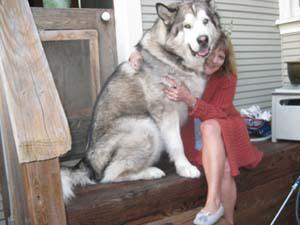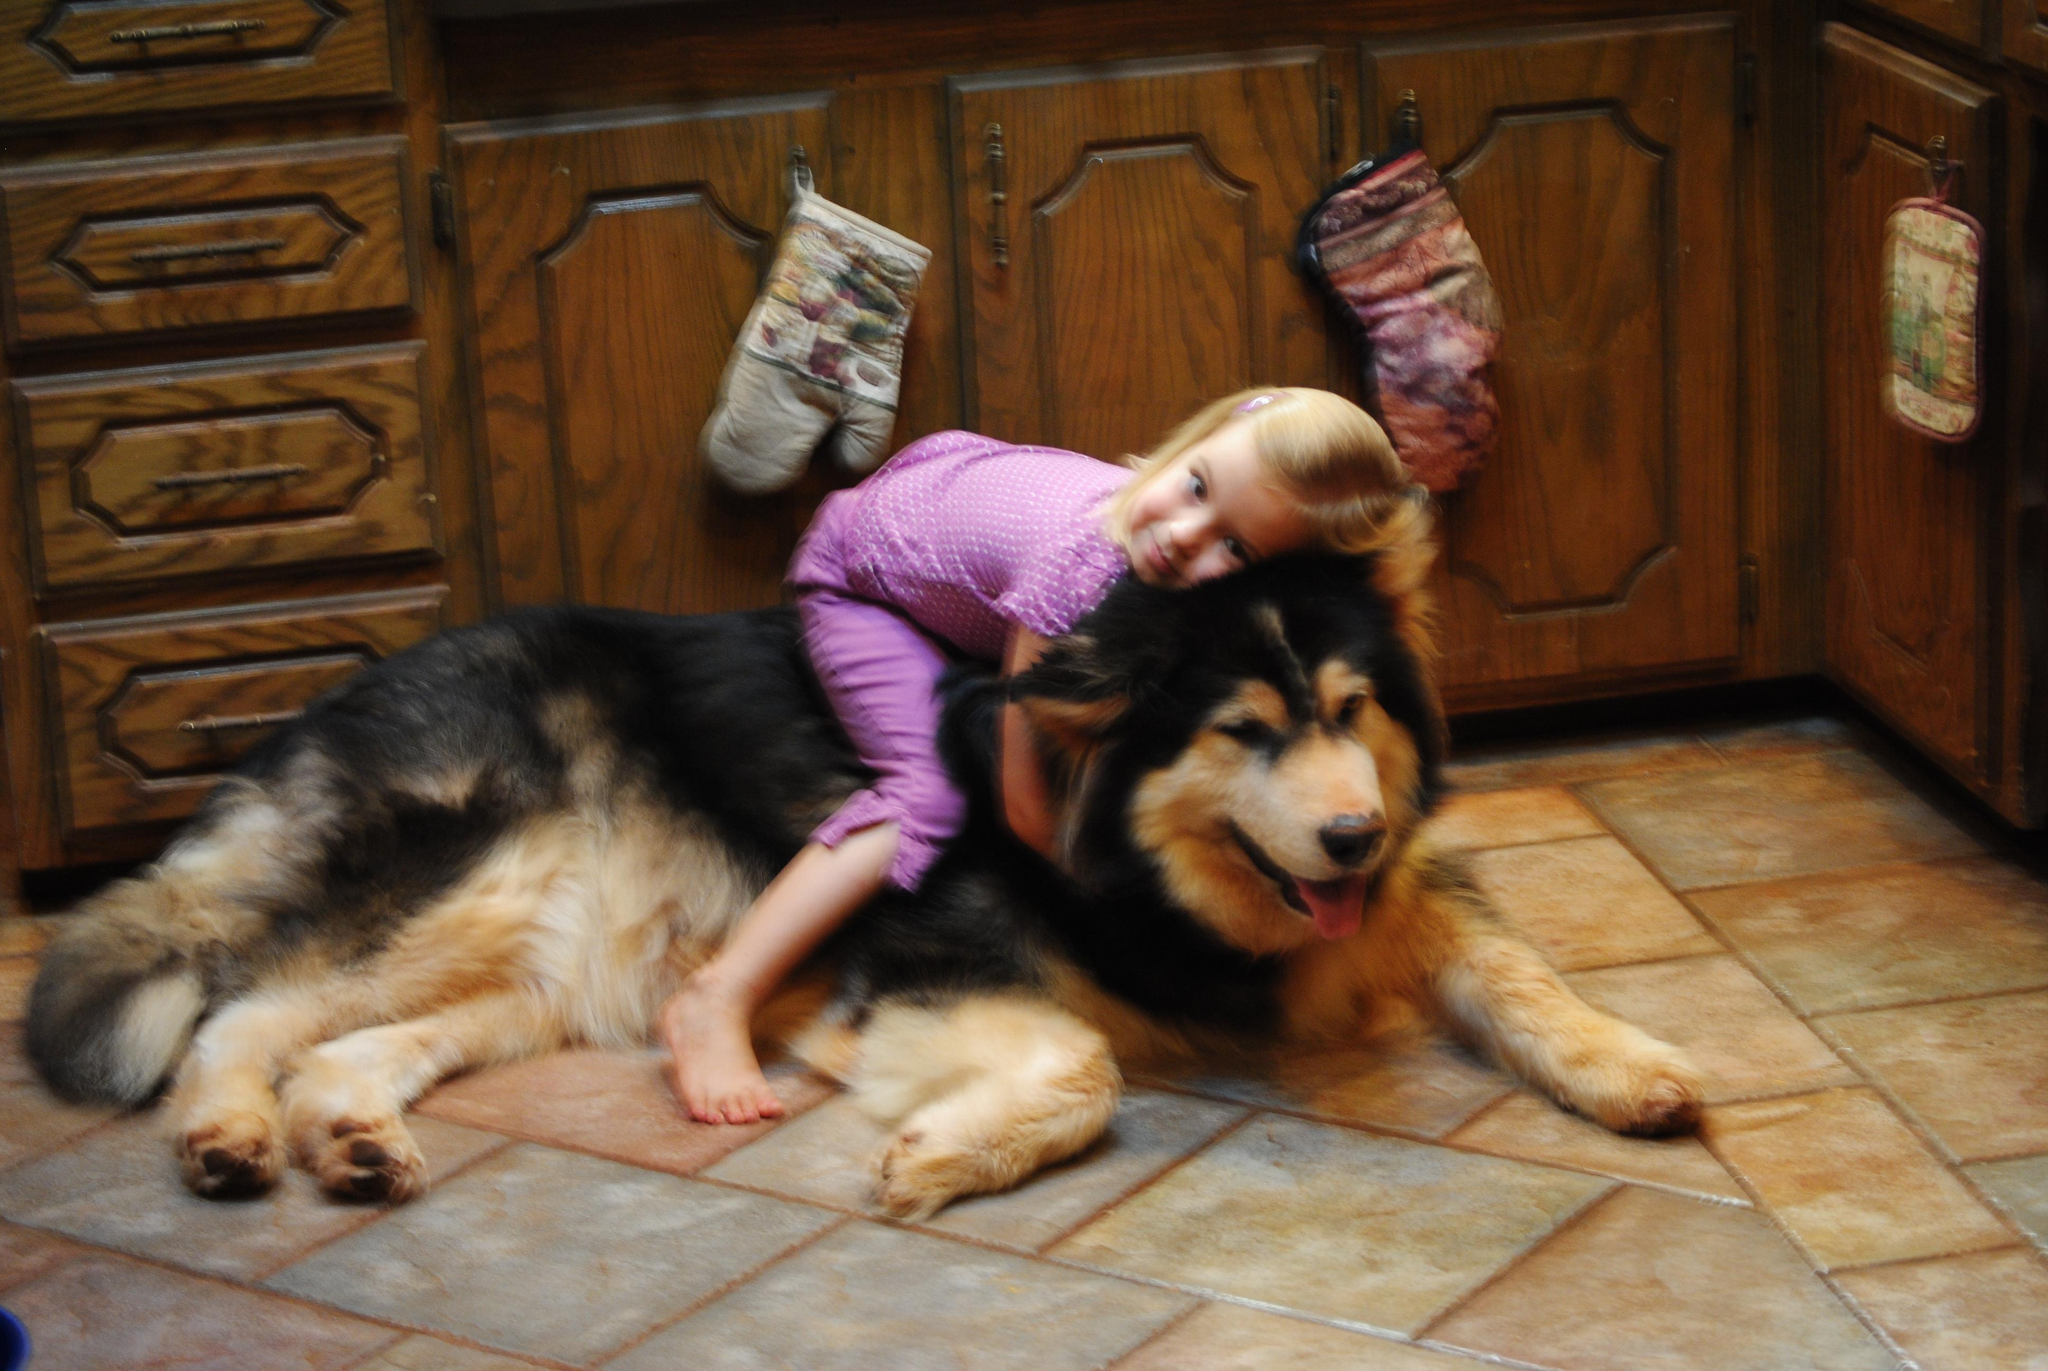The first image is the image on the left, the second image is the image on the right. Considering the images on both sides, is "In the right image, a little girl is hugging a big dog and laying the side of her head against it." valid? Answer yes or no. Yes. The first image is the image on the left, the second image is the image on the right. Given the left and right images, does the statement "The left and right image contains the same number of dogs." hold true? Answer yes or no. Yes. 